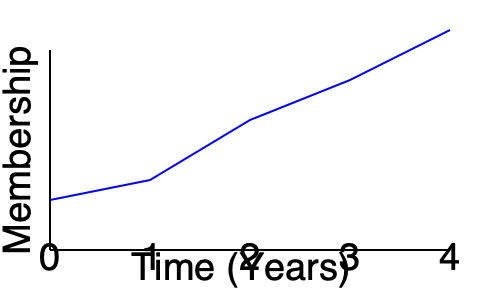The graph shows the growth of an online support group's membership over a 4-year period. Using the compound annual growth rate (CAGR) formula, calculate the average yearly growth rate of the group's membership. Round your answer to the nearest whole percentage. To solve this problem, we'll follow these steps:

1. Identify the initial and final values from the graph:
   Initial value (Year 0): Approximately 50 members
   Final value (Year 4): Approximately 220 members

2. Recall the CAGR formula:
   $CAGR = \left(\frac{Ending Value}{Beginning Value}\right)^{\frac{1}{n}} - 1$
   Where $n$ is the number of years

3. Plug in the values:
   $CAGR = \left(\frac{220}{50}\right)^{\frac{1}{4}} - 1$

4. Calculate:
   $CAGR = (4.4)^{0.25} - 1$
   $CAGR = 1.4491 - 1$
   $CAGR = 0.4491$

5. Convert to a percentage:
   $0.4491 \times 100 = 44.91\%$

6. Round to the nearest whole percentage:
   $44.91\% \approx 45\%$

Therefore, the average yearly growth rate of the group's membership is approximately 45%.
Answer: 45% 